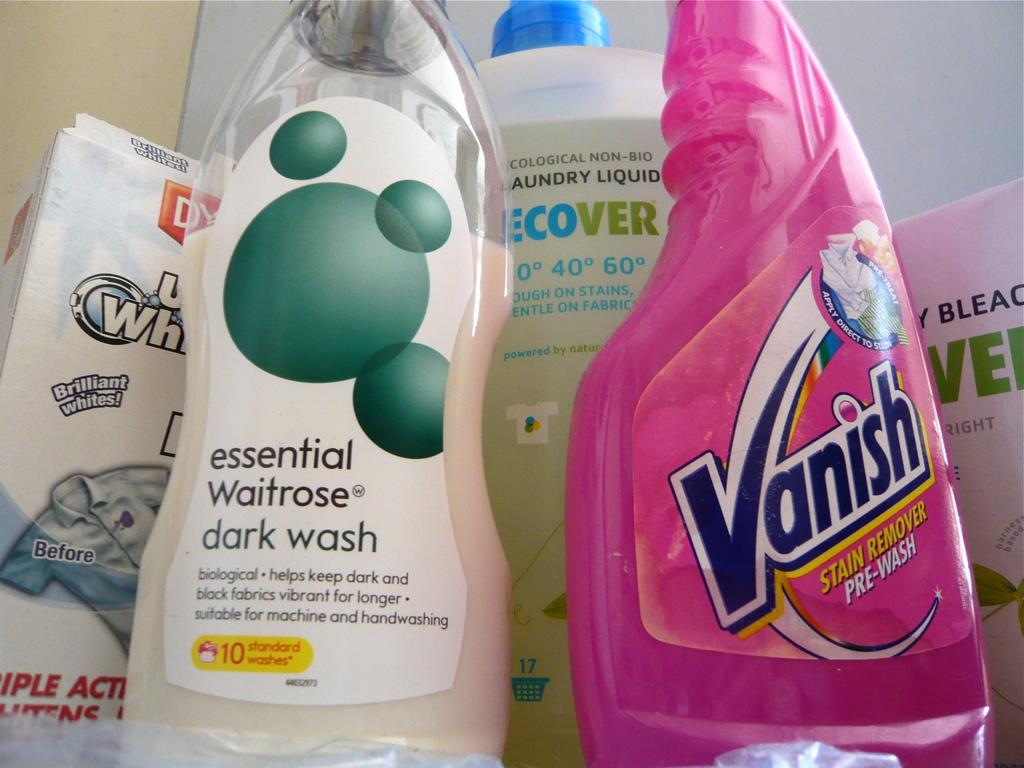<image>
Present a compact description of the photo's key features. Amongst other cleaning supplies is a pink bottle of Vanish stain remover. 